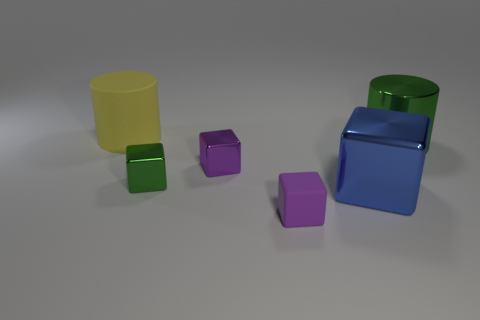Add 3 large blue blocks. How many objects exist? 9 Subtract all brown blocks. Subtract all green balls. How many blocks are left? 4 Subtract all cubes. How many objects are left? 2 Subtract all large metal objects. Subtract all large objects. How many objects are left? 1 Add 2 large metal cylinders. How many large metal cylinders are left? 3 Add 6 brown metal cubes. How many brown metal cubes exist? 6 Subtract 0 red cylinders. How many objects are left? 6 